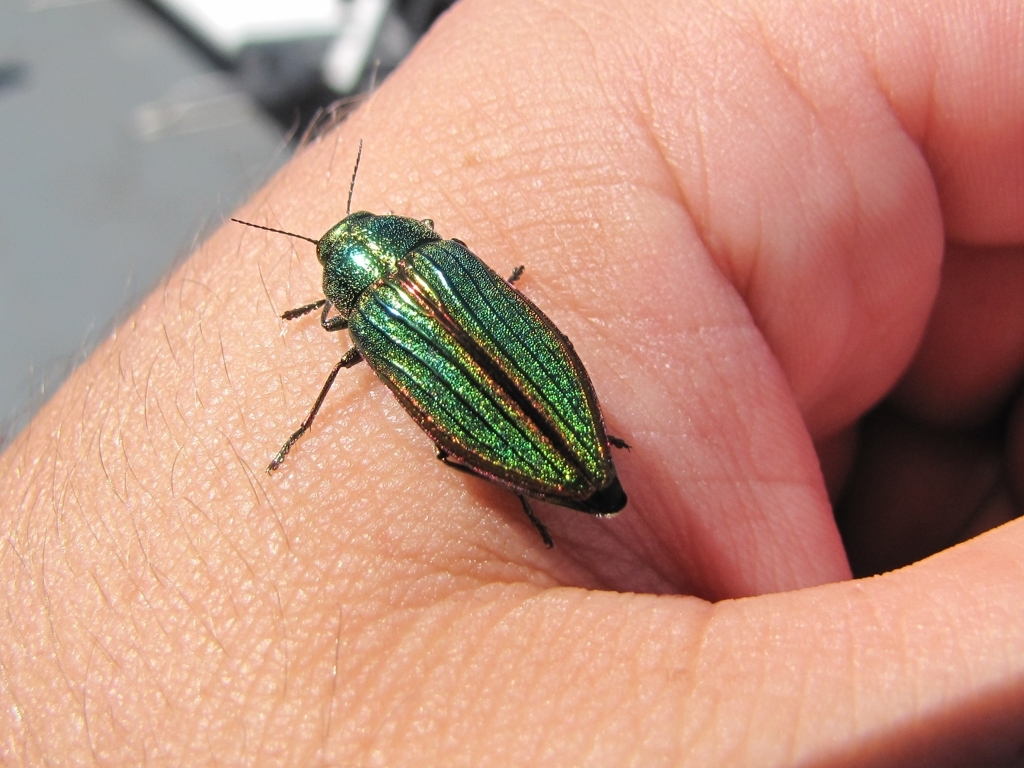How clear are the pattern details on the insect's body? The patterning on the insect's exoskeleton is exceptionally clear and detailed, showcasing vivid iridescence with streaks of emerald and occasionally hints of other colors reflecting light in a brilliant display. This sharp clarity of pattern can provide insights into the insect's species, health, and potential for camouflage or mate attraction. 